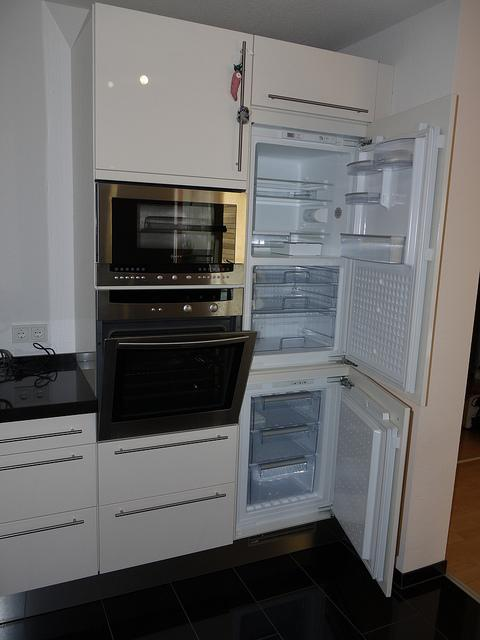The kitchen adheres to the electrical standards set in which region? europe 